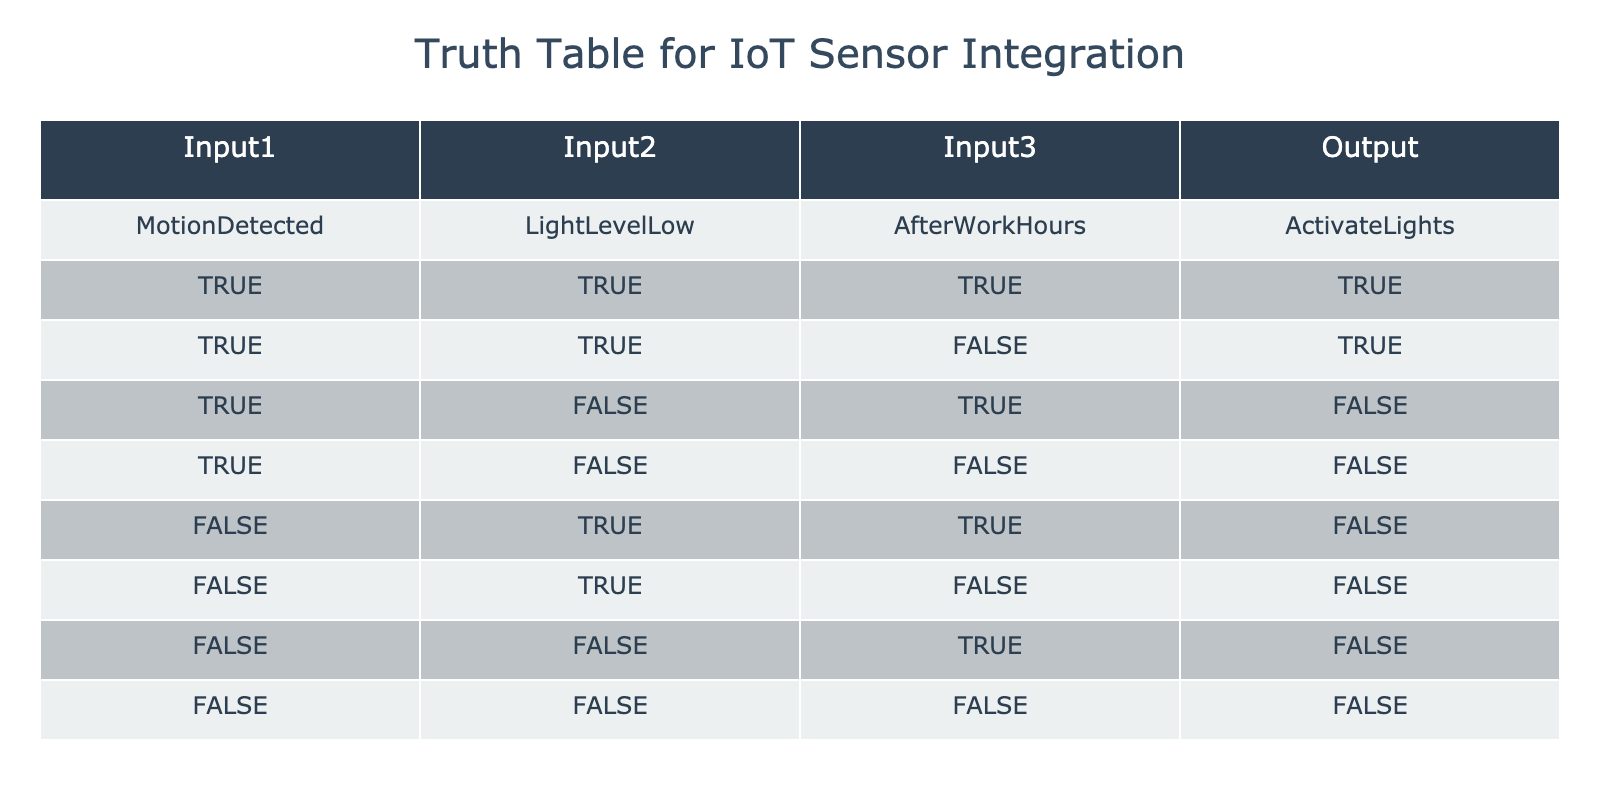What is the output when all inputs are true? In the table, we can see the second row represents the case where all inputs (MotionDetected, LightLevelLow, and AfterWorkHours) are true. According to the Output column for this row, the result is 'ActivateLights'.
Answer: ActivateLights How many scenarios result in activating the lights? To determine this, we count the rows where the Output is 'ActivateLights'. The first and second rows both indicate that the output is 'ActivateLights', leading to a total of 2 scenarios.
Answer: 2 If the MotionDetected input is false, what is the output? Looking at the table, there are three cases where MotionDetected is false (rows 5, 6, and 7). In all of these cases, the output is 'FALSE'.
Answer: FALSE Is it ever the case that lights are activated when it is not after work hours? By checking the rows where AfterWorkHours is false, we find that the outputs are in the third (FALSE) and fourth (FALSE) rows. Since there are no rows outputting 'TRUE' for ActivateLights while AfterWorkHours is false, the answer is no.
Answer: No What are the conditions required to activate the lights? To activate the lights, we look for rows with 'TRUE' in the Output column. The first and second rows show that the conditions required are MotionDetected = TRUE, LightLevelLow = TRUE (regardless of AfterWorkHours value).
Answer: MotionDetected = TRUE, LightLevelLow = TRUE 